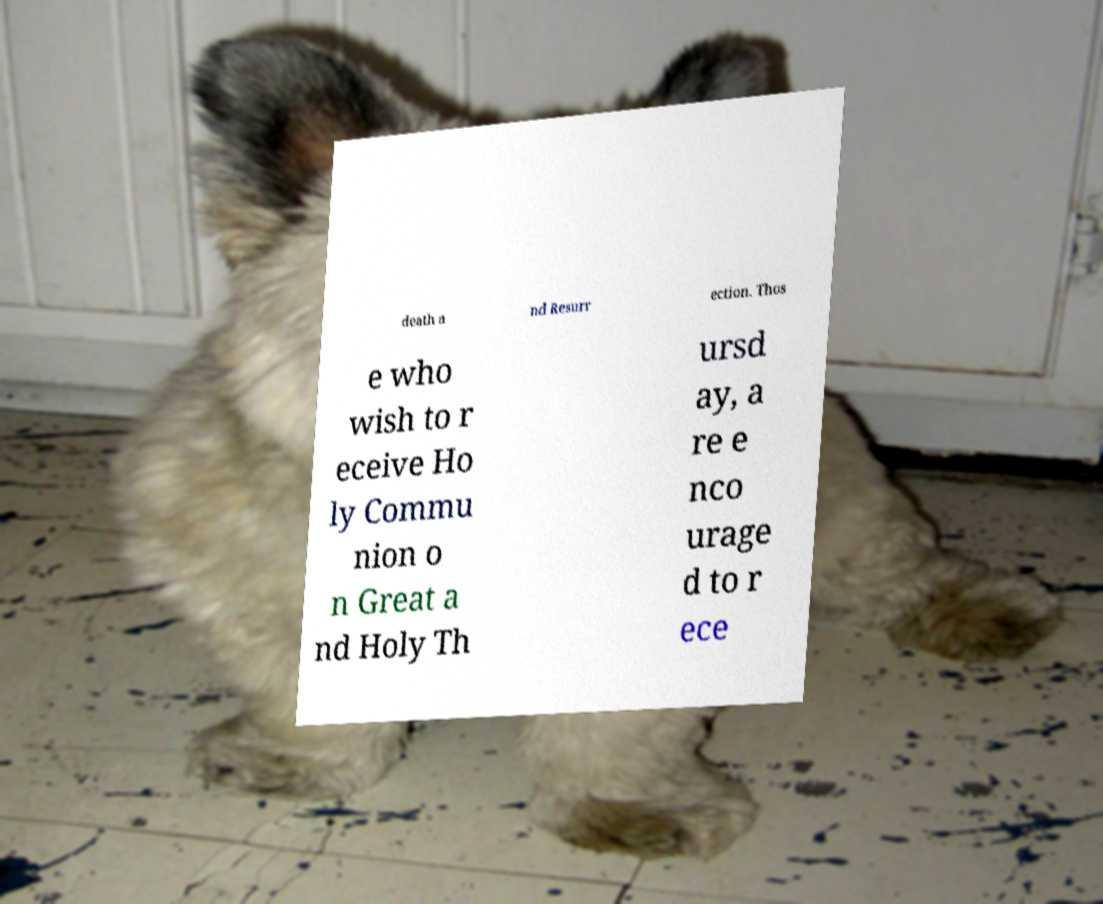What messages or text are displayed in this image? I need them in a readable, typed format. death a nd Resurr ection. Thos e who wish to r eceive Ho ly Commu nion o n Great a nd Holy Th ursd ay, a re e nco urage d to r ece 